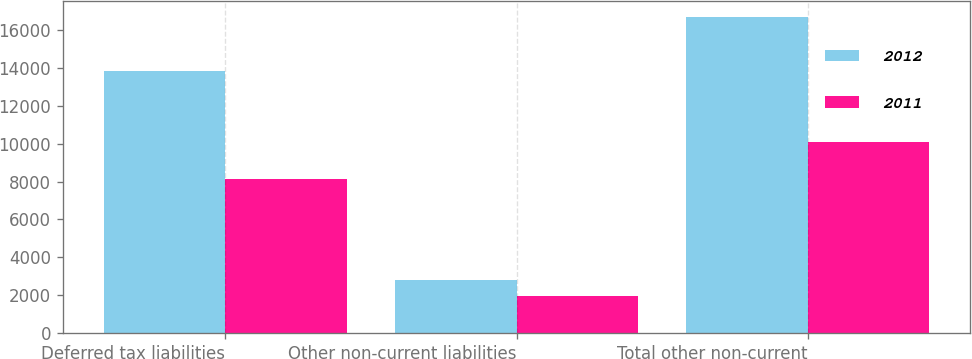Convert chart. <chart><loc_0><loc_0><loc_500><loc_500><stacked_bar_chart><ecel><fcel>Deferred tax liabilities<fcel>Other non-current liabilities<fcel>Total other non-current<nl><fcel>2012<fcel>13847<fcel>2817<fcel>16664<nl><fcel>2011<fcel>8159<fcel>1941<fcel>10100<nl></chart> 